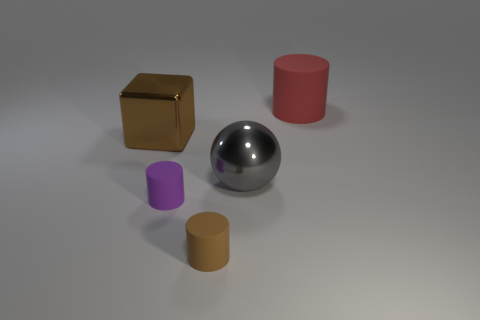Add 5 small red metal cylinders. How many objects exist? 10 Subtract all spheres. How many objects are left? 4 Add 1 matte things. How many matte things exist? 4 Subtract 0 red cubes. How many objects are left? 5 Subtract all tiny cyan metallic blocks. Subtract all tiny brown rubber cylinders. How many objects are left? 4 Add 2 purple rubber things. How many purple rubber things are left? 3 